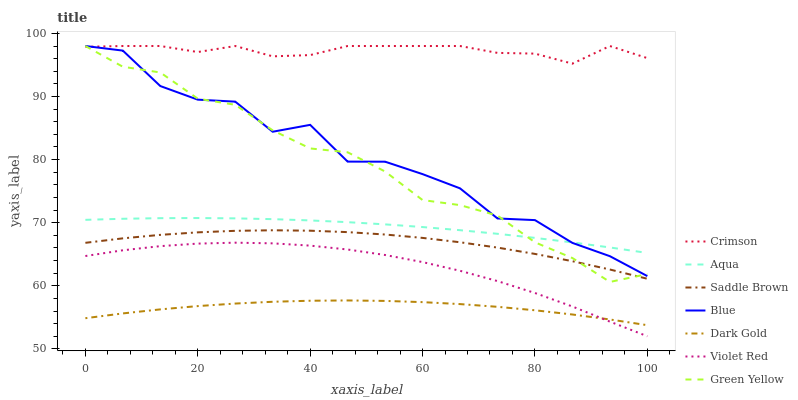Does Dark Gold have the minimum area under the curve?
Answer yes or no. Yes. Does Crimson have the maximum area under the curve?
Answer yes or no. Yes. Does Violet Red have the minimum area under the curve?
Answer yes or no. No. Does Violet Red have the maximum area under the curve?
Answer yes or no. No. Is Aqua the smoothest?
Answer yes or no. Yes. Is Blue the roughest?
Answer yes or no. Yes. Is Violet Red the smoothest?
Answer yes or no. No. Is Violet Red the roughest?
Answer yes or no. No. Does Violet Red have the lowest value?
Answer yes or no. Yes. Does Dark Gold have the lowest value?
Answer yes or no. No. Does Green Yellow have the highest value?
Answer yes or no. Yes. Does Violet Red have the highest value?
Answer yes or no. No. Is Violet Red less than Aqua?
Answer yes or no. Yes. Is Crimson greater than Aqua?
Answer yes or no. Yes. Does Green Yellow intersect Saddle Brown?
Answer yes or no. Yes. Is Green Yellow less than Saddle Brown?
Answer yes or no. No. Is Green Yellow greater than Saddle Brown?
Answer yes or no. No. Does Violet Red intersect Aqua?
Answer yes or no. No. 